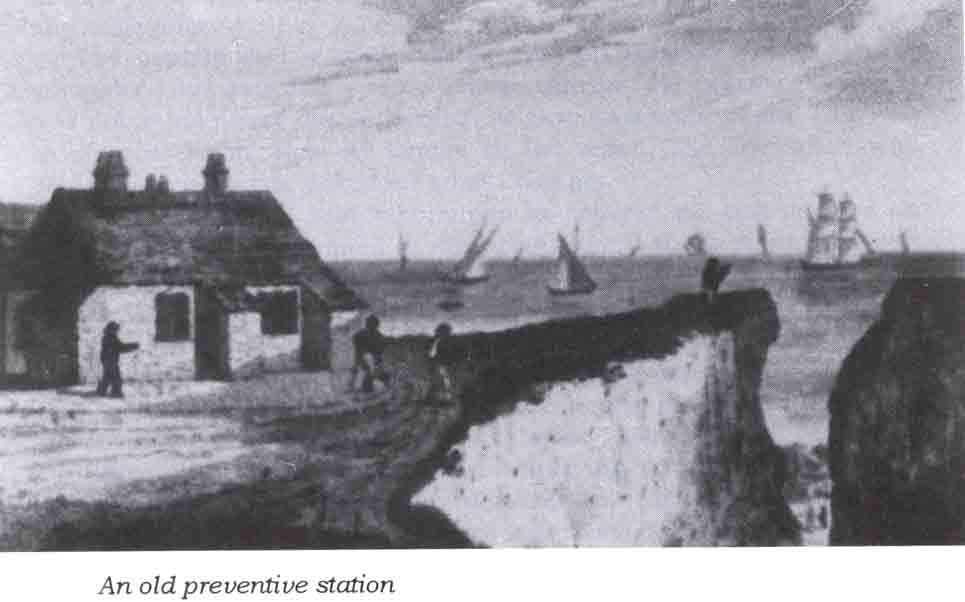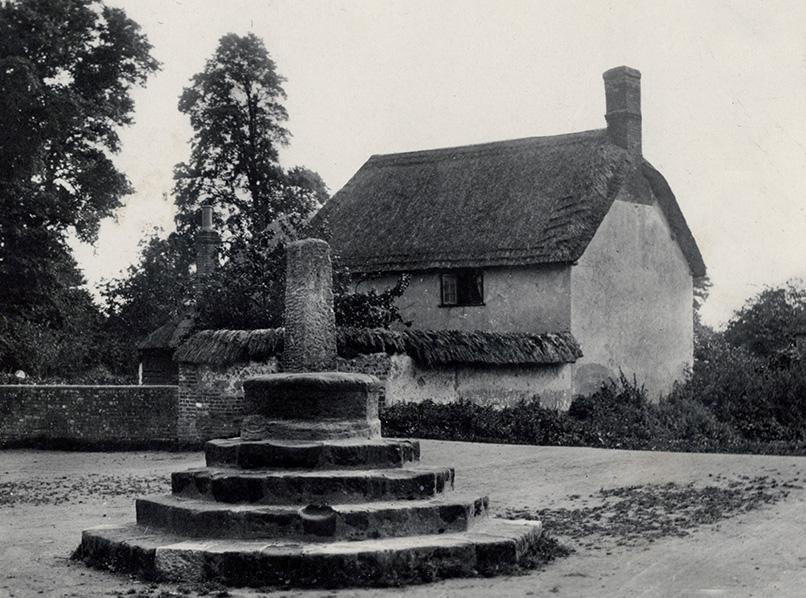The first image is the image on the left, the second image is the image on the right. For the images shown, is this caption "Two houses have chimneys." true? Answer yes or no. Yes. The first image is the image on the left, the second image is the image on the right. Examine the images to the left and right. Is the description "The right image features palm trees behind at least one primitive structure with a peaked thatch roof." accurate? Answer yes or no. No. 